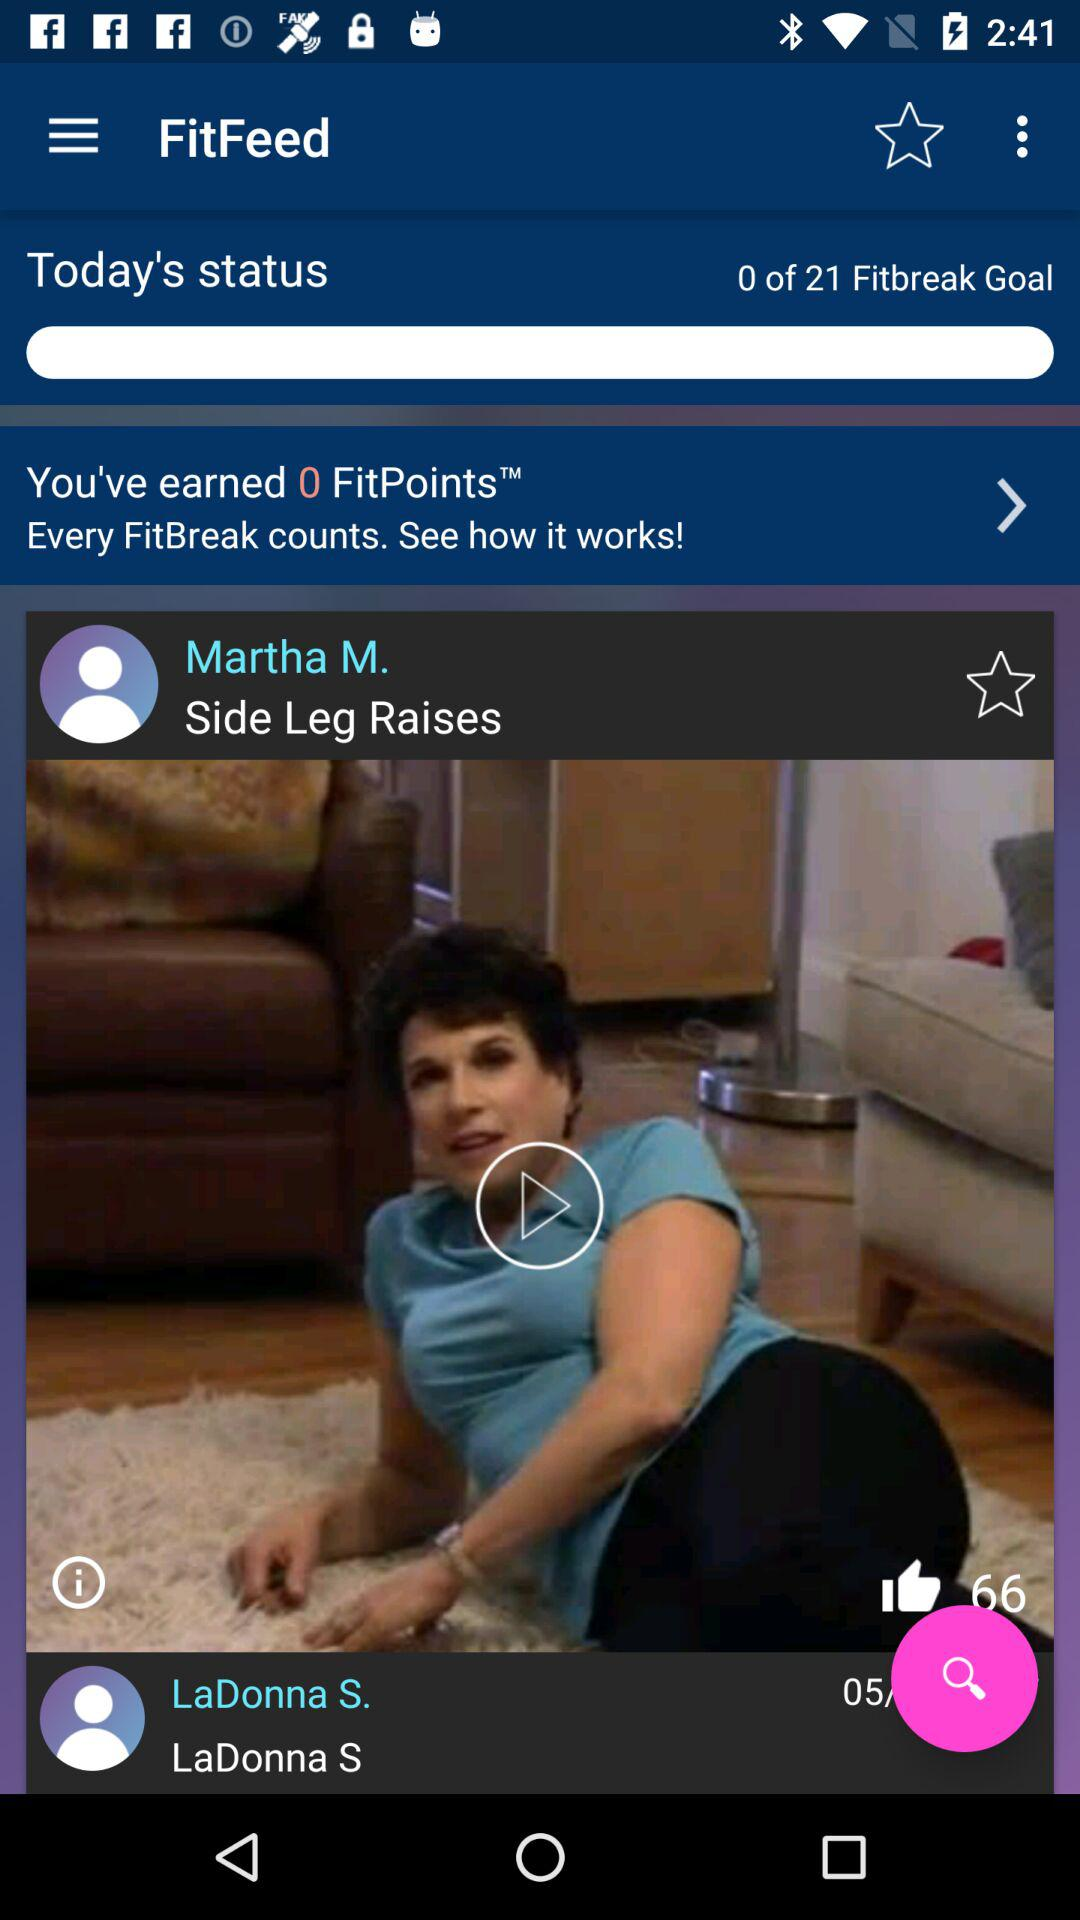What is the number of likes? The number of likes is 66. 